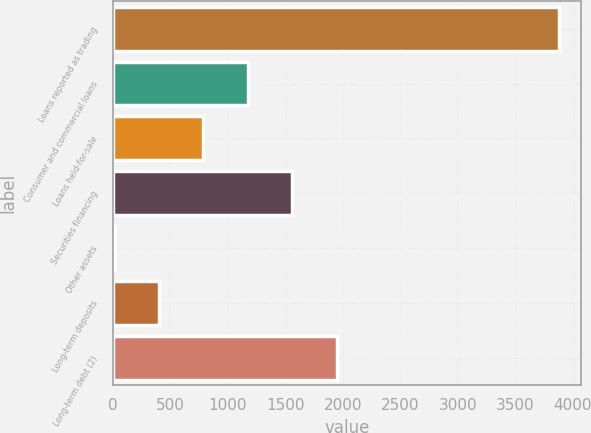<chart> <loc_0><loc_0><loc_500><loc_500><bar_chart><fcel>Loans reported as trading<fcel>Consumer and commercial loans<fcel>Loans held-for-sale<fcel>Securities financing<fcel>Other assets<fcel>Long-term deposits<fcel>Long-term debt (2)<nl><fcel>3880<fcel>1175.9<fcel>789.6<fcel>1562.2<fcel>17<fcel>403.3<fcel>1948.5<nl></chart> 